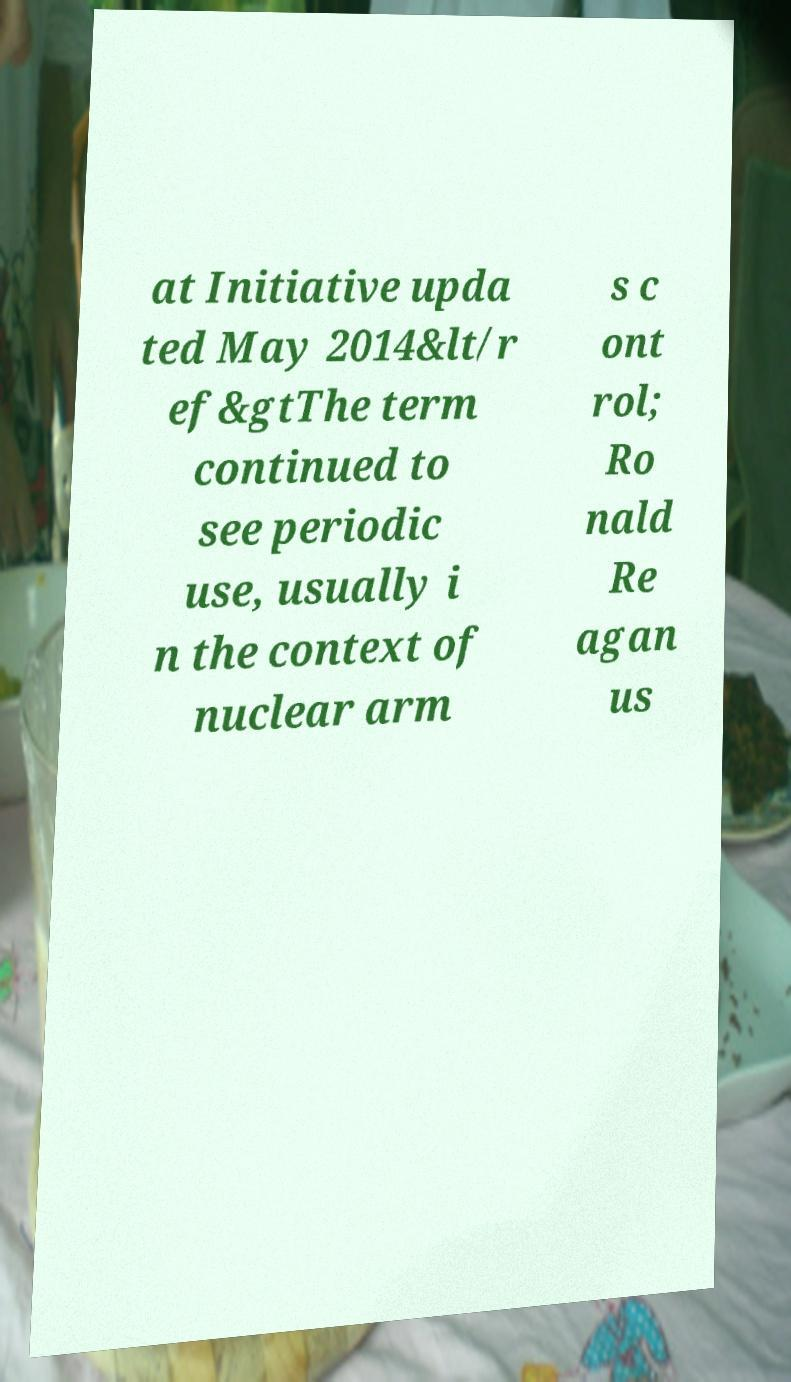What messages or text are displayed in this image? I need them in a readable, typed format. at Initiative upda ted May 2014&lt/r ef&gtThe term continued to see periodic use, usually i n the context of nuclear arm s c ont rol; Ro nald Re agan us 